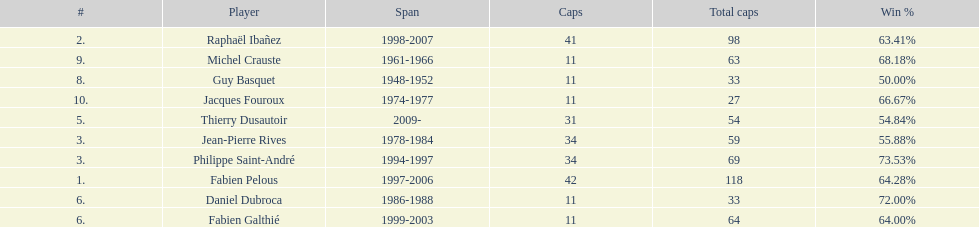Could you parse the entire table as a dict? {'header': ['#', 'Player', 'Span', 'Caps', 'Total caps', 'Win\xa0%'], 'rows': [['2.', 'Raphaël Ibañez', '1998-2007', '41', '98', '63.41%'], ['9.', 'Michel Crauste', '1961-1966', '11', '63', '68.18%'], ['8.', 'Guy Basquet', '1948-1952', '11', '33', '50.00%'], ['10.', 'Jacques Fouroux', '1974-1977', '11', '27', '66.67%'], ['5.', 'Thierry Dusautoir', '2009-', '31', '54', '54.84%'], ['3.', 'Jean-Pierre Rives', '1978-1984', '34', '59', '55.88%'], ['3.', 'Philippe Saint-André', '1994-1997', '34', '69', '73.53%'], ['1.', 'Fabien Pelous', '1997-2006', '42', '118', '64.28%'], ['6.', 'Daniel Dubroca', '1986-1988', '11', '33', '72.00%'], ['6.', 'Fabien Galthié', '1999-2003', '11', '64', '64.00%']]} How many players have spans above three years? 6. 